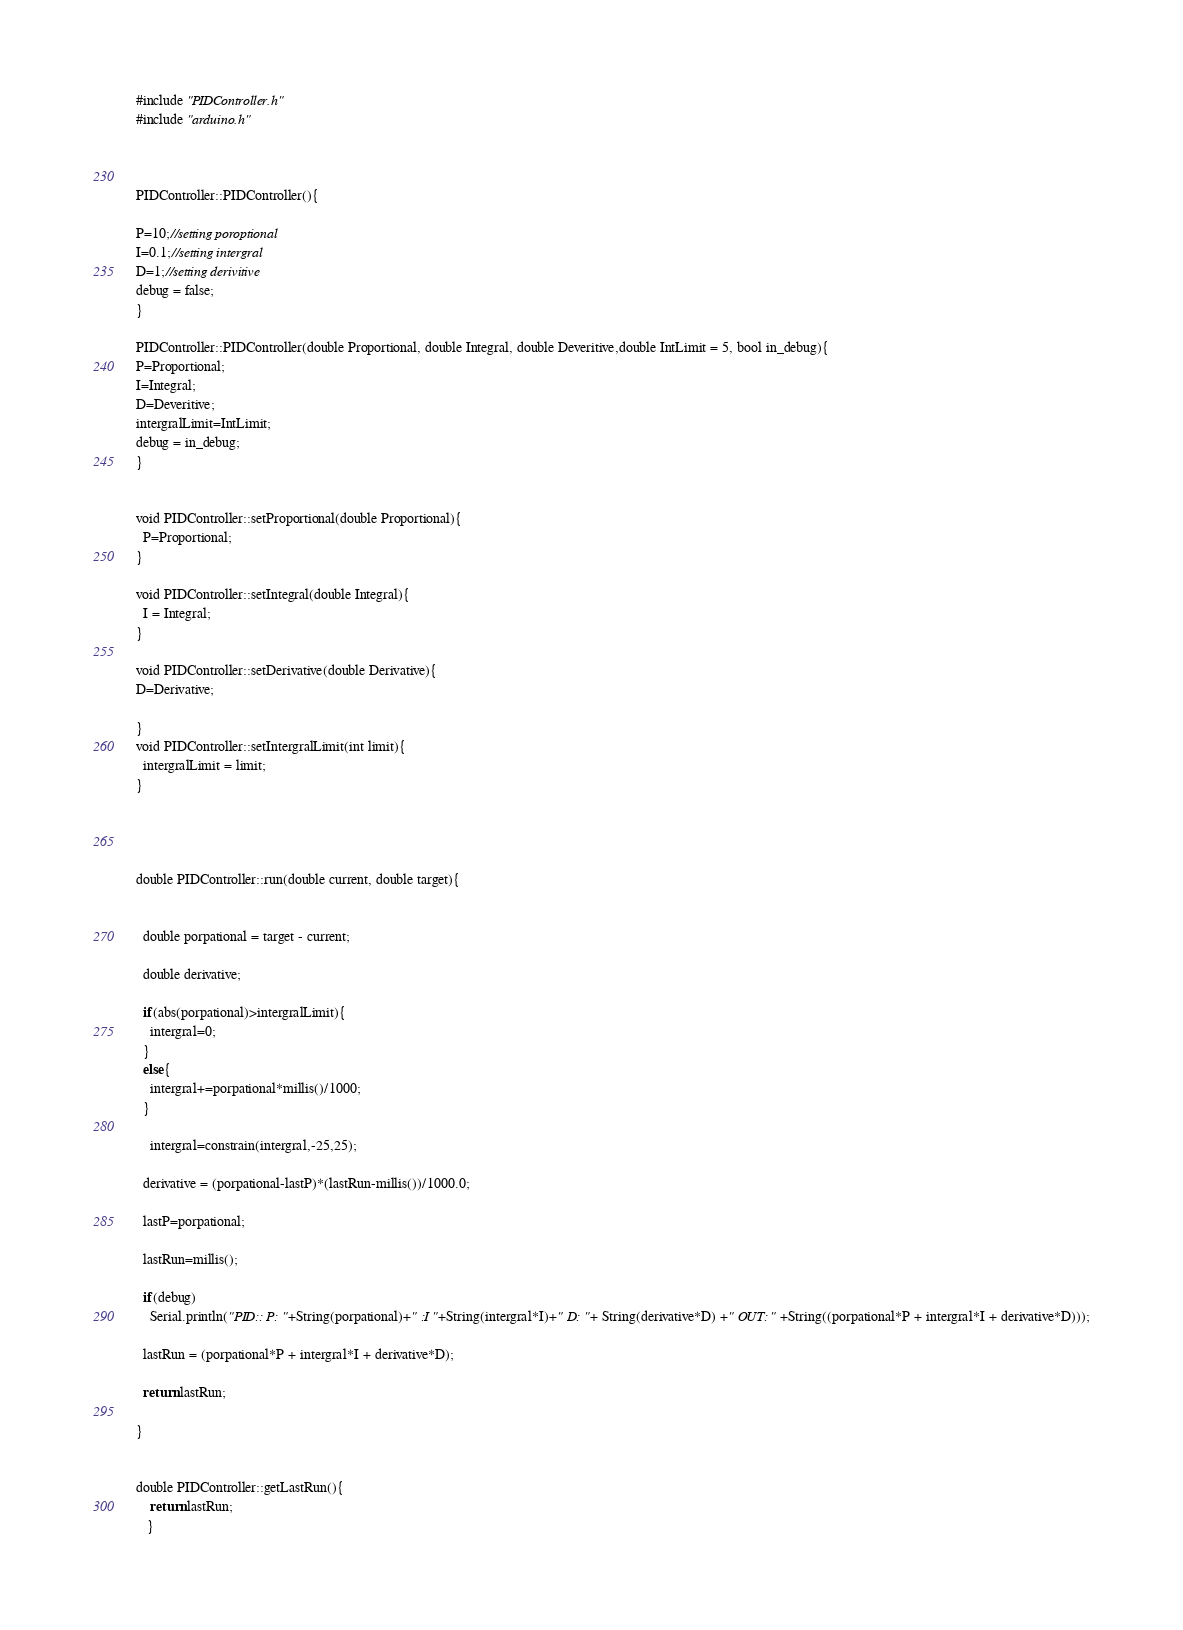Convert code to text. <code><loc_0><loc_0><loc_500><loc_500><_C++_>#include "PIDController.h"
#include "arduino.h"



PIDController::PIDController(){

P=10;//setting poroptional
I=0.1;//setting intergral
D=1;//setting derivitive
debug = false;
}

PIDController::PIDController(double Proportional, double Integral, double Deveritive,double IntLimit = 5, bool in_debug){
P=Proportional;
I=Integral;
D=Deveritive;
intergralLimit=IntLimit;
debug = in_debug;
}


void PIDController::setProportional(double Proportional){
  P=Proportional;
}

void PIDController::setIntegral(double Integral){
  I = Integral;
}

void PIDController::setDerivative(double Derivative){
D=Derivative;
  
}
void PIDController::setIntergralLimit(int limit){
  intergralLimit = limit;
}




double PIDController::run(double current, double target){

  
  double porpational = target - current;
  
  double derivative;

  if(abs(porpational)>intergralLimit){
    intergral=0;
  }
  else{
    intergral+=porpational*millis()/1000;
  }

    intergral=constrain(intergral,-25,25);

  derivative = (porpational-lastP)*(lastRun-millis())/1000.0;

  lastP=porpational;
  
  lastRun=millis();
  
  if(debug)
    Serial.println("PID:: P: "+String(porpational)+" :I "+String(intergral*I)+" D: "+ String(derivative*D) +" OUT:" +String((porpational*P + intergral*I + derivative*D)));
    
  lastRun = (porpational*P + intergral*I + derivative*D);
  
  return lastRun;
  
}


double PIDController::getLastRun(){
    return lastRun;
   }
</code> 